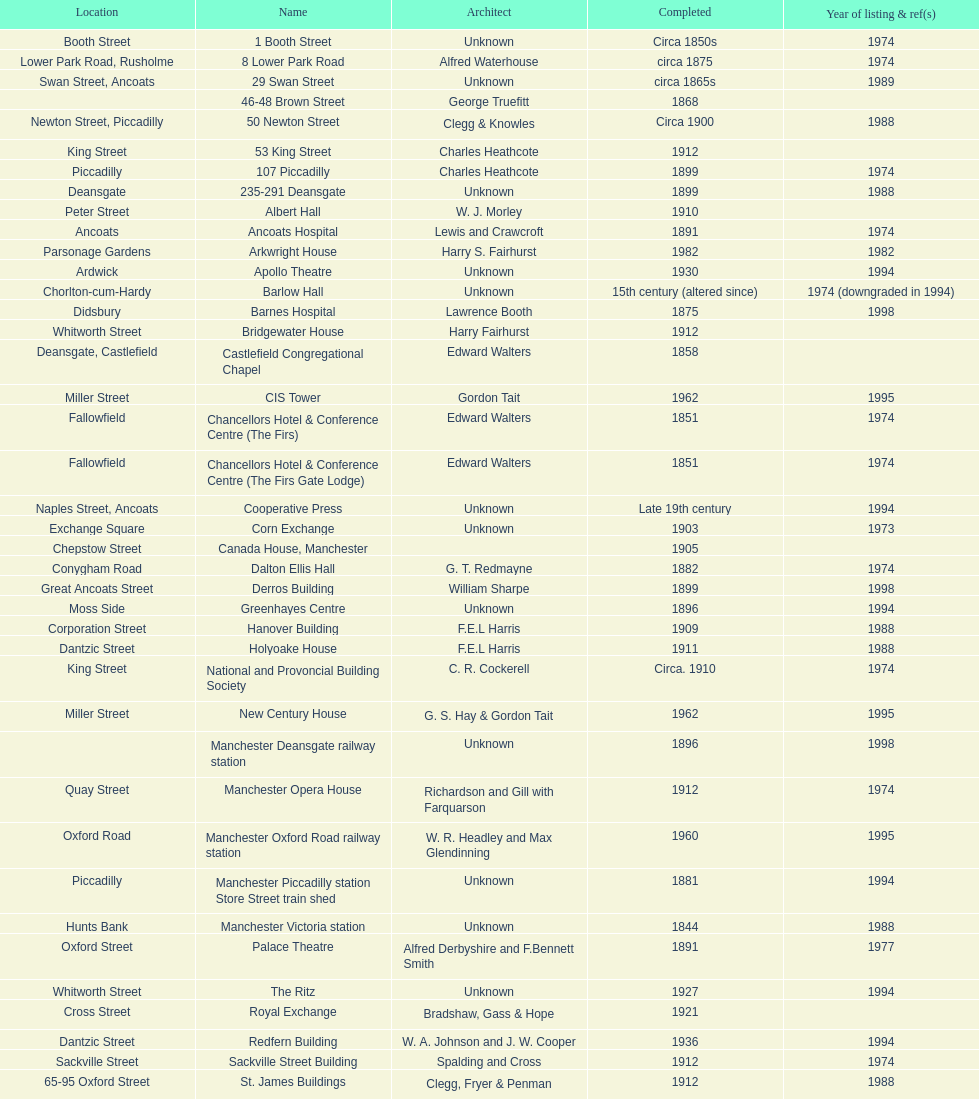Which year has the most buildings listed? 1974. Parse the table in full. {'header': ['Location', 'Name', 'Architect', 'Completed', 'Year of listing & ref(s)'], 'rows': [['Booth Street', '1 Booth Street', 'Unknown', 'Circa 1850s', '1974'], ['Lower Park Road, Rusholme', '8 Lower Park Road', 'Alfred Waterhouse', 'circa 1875', '1974'], ['Swan Street, Ancoats', '29 Swan Street', 'Unknown', 'circa 1865s', '1989'], ['', '46-48 Brown Street', 'George Truefitt', '1868', ''], ['Newton Street, Piccadilly', '50 Newton Street', 'Clegg & Knowles', 'Circa 1900', '1988'], ['King Street', '53 King Street', 'Charles Heathcote', '1912', ''], ['Piccadilly', '107 Piccadilly', 'Charles Heathcote', '1899', '1974'], ['Deansgate', '235-291 Deansgate', 'Unknown', '1899', '1988'], ['Peter Street', 'Albert Hall', 'W. J. Morley', '1910', ''], ['Ancoats', 'Ancoats Hospital', 'Lewis and Crawcroft', '1891', '1974'], ['Parsonage Gardens', 'Arkwright House', 'Harry S. Fairhurst', '1982', '1982'], ['Ardwick', 'Apollo Theatre', 'Unknown', '1930', '1994'], ['Chorlton-cum-Hardy', 'Barlow Hall', 'Unknown', '15th century (altered since)', '1974 (downgraded in 1994)'], ['Didsbury', 'Barnes Hospital', 'Lawrence Booth', '1875', '1998'], ['Whitworth Street', 'Bridgewater House', 'Harry Fairhurst', '1912', ''], ['Deansgate, Castlefield', 'Castlefield Congregational Chapel', 'Edward Walters', '1858', ''], ['Miller Street', 'CIS Tower', 'Gordon Tait', '1962', '1995'], ['Fallowfield', 'Chancellors Hotel & Conference Centre (The Firs)', 'Edward Walters', '1851', '1974'], ['Fallowfield', 'Chancellors Hotel & Conference Centre (The Firs Gate Lodge)', 'Edward Walters', '1851', '1974'], ['Naples Street, Ancoats', 'Cooperative Press', 'Unknown', 'Late 19th century', '1994'], ['Exchange Square', 'Corn Exchange', 'Unknown', '1903', '1973'], ['Chepstow Street', 'Canada House, Manchester', '', '1905', ''], ['Conygham Road', 'Dalton Ellis Hall', 'G. T. Redmayne', '1882', '1974'], ['Great Ancoats Street', 'Derros Building', 'William Sharpe', '1899', '1998'], ['Moss Side', 'Greenhayes Centre', 'Unknown', '1896', '1994'], ['Corporation Street', 'Hanover Building', 'F.E.L Harris', '1909', '1988'], ['Dantzic Street', 'Holyoake House', 'F.E.L Harris', '1911', '1988'], ['King Street', 'National and Provoncial Building Society', 'C. R. Cockerell', 'Circa. 1910', '1974'], ['Miller Street', 'New Century House', 'G. S. Hay & Gordon Tait', '1962', '1995'], ['', 'Manchester Deansgate railway station', 'Unknown', '1896', '1998'], ['Quay Street', 'Manchester Opera House', 'Richardson and Gill with Farquarson', '1912', '1974'], ['Oxford Road', 'Manchester Oxford Road railway station', 'W. R. Headley and Max Glendinning', '1960', '1995'], ['Piccadilly', 'Manchester Piccadilly station Store Street train shed', 'Unknown', '1881', '1994'], ['Hunts Bank', 'Manchester Victoria station', 'Unknown', '1844', '1988'], ['Oxford Street', 'Palace Theatre', 'Alfred Derbyshire and F.Bennett Smith', '1891', '1977'], ['Whitworth Street', 'The Ritz', 'Unknown', '1927', '1994'], ['Cross Street', 'Royal Exchange', 'Bradshaw, Gass & Hope', '1921', ''], ['Dantzic Street', 'Redfern Building', 'W. A. Johnson and J. W. Cooper', '1936', '1994'], ['Sackville Street', 'Sackville Street Building', 'Spalding and Cross', '1912', '1974'], ['65-95 Oxford Street', 'St. James Buildings', 'Clegg, Fryer & Penman', '1912', '1988'], ['Wilmslow Road', "St Mary's Hospital", 'John Ely', '1909', '1994'], ['Oxford Road', 'Samuel Alexander Building', 'Percy Scott Worthington', '1919', '2010'], ['King Street', 'Ship Canal House', 'Harry S. Fairhurst', '1927', '1982'], ['Swan Street, Ancoats', 'Smithfield Market Hall', 'Unknown', '1857', '1973'], ['Sherborne Street', 'Strangeways Gaol Gatehouse', 'Alfred Waterhouse', '1868', '1974'], ['Sherborne Street', 'Strangeways Prison ventilation and watch tower', 'Alfred Waterhouse', '1868', '1974'], ['Peter Street', 'Theatre Royal', 'Irwin and Chester', '1845', '1974'], ['Fallowfield', 'Toast Rack', 'L. C. Howitt', '1960', '1999'], ['Shambles Square', 'The Old Wellington Inn', 'Unknown', 'Mid-16th century', '1952'], ['Whitworth Park', 'Whitworth Park Mansions', 'Unknown', 'Circa 1840s', '1974']]} 